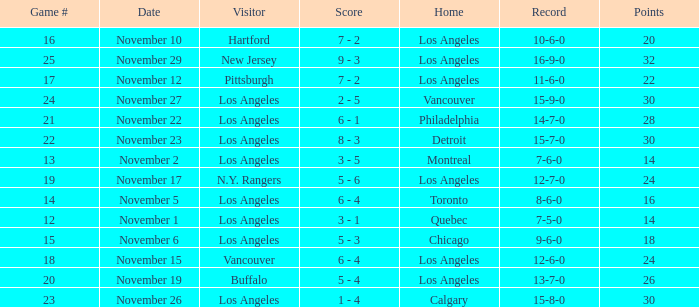What is the number of points of the game less than number 17 with an 11-6-0 record? None. 